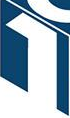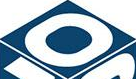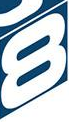Transcribe the words shown in these images in order, separated by a semicolon. 1; 0; 8 